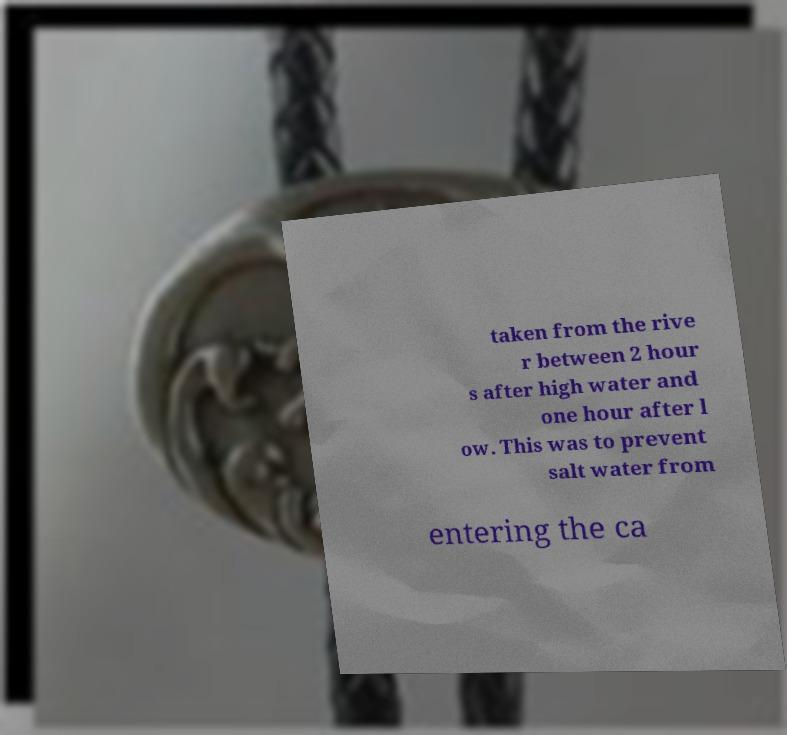What messages or text are displayed in this image? I need them in a readable, typed format. taken from the rive r between 2 hour s after high water and one hour after l ow. This was to prevent salt water from entering the ca 